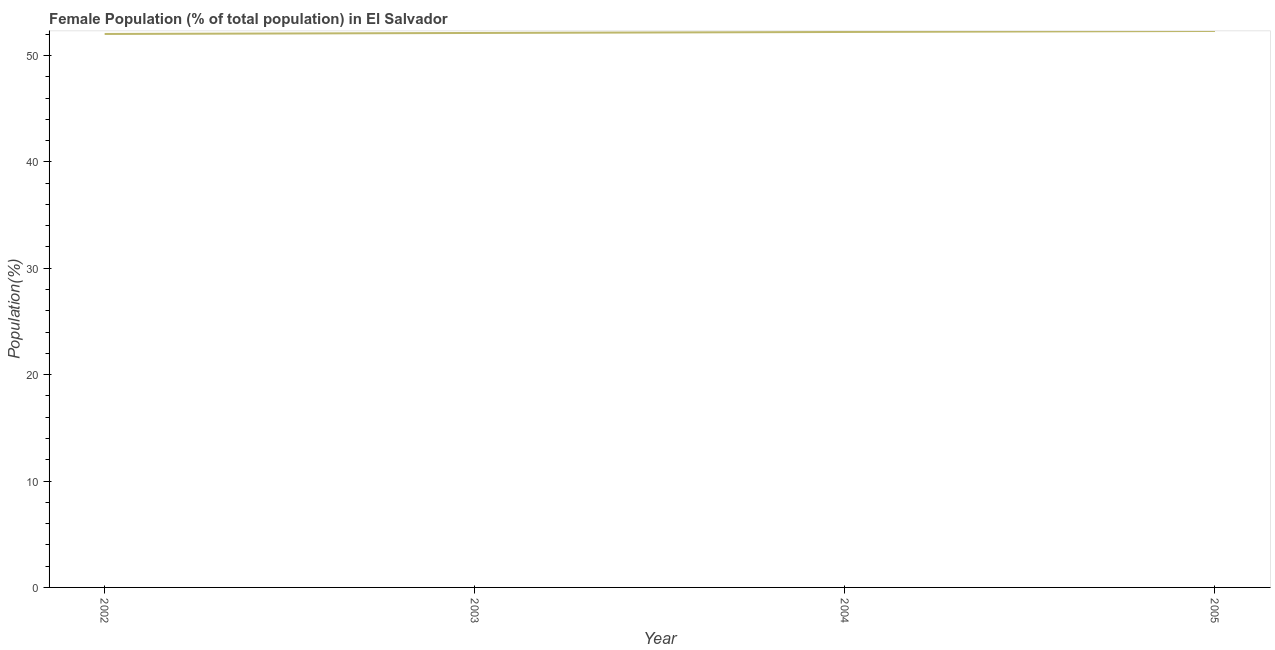What is the female population in 2004?
Make the answer very short. 52.21. Across all years, what is the maximum female population?
Ensure brevity in your answer.  52.3. Across all years, what is the minimum female population?
Offer a very short reply. 52.02. In which year was the female population maximum?
Your response must be concise. 2005. What is the sum of the female population?
Give a very brief answer. 208.65. What is the difference between the female population in 2003 and 2004?
Keep it short and to the point. -0.09. What is the average female population per year?
Provide a succinct answer. 52.16. What is the median female population?
Offer a very short reply. 52.16. In how many years, is the female population greater than 30 %?
Give a very brief answer. 4. What is the ratio of the female population in 2002 to that in 2004?
Your answer should be compact. 1. Is the female population in 2002 less than that in 2004?
Keep it short and to the point. Yes. What is the difference between the highest and the second highest female population?
Your response must be concise. 0.09. Is the sum of the female population in 2003 and 2004 greater than the maximum female population across all years?
Provide a succinct answer. Yes. What is the difference between the highest and the lowest female population?
Your response must be concise. 0.28. In how many years, is the female population greater than the average female population taken over all years?
Offer a terse response. 2. Does the female population monotonically increase over the years?
Ensure brevity in your answer.  Yes. How many lines are there?
Make the answer very short. 1. What is the title of the graph?
Ensure brevity in your answer.  Female Population (% of total population) in El Salvador. What is the label or title of the Y-axis?
Give a very brief answer. Population(%). What is the Population(%) in 2002?
Your answer should be compact. 52.02. What is the Population(%) of 2003?
Your response must be concise. 52.12. What is the Population(%) of 2004?
Your response must be concise. 52.21. What is the Population(%) of 2005?
Your answer should be very brief. 52.3. What is the difference between the Population(%) in 2002 and 2003?
Your answer should be very brief. -0.09. What is the difference between the Population(%) in 2002 and 2004?
Provide a succinct answer. -0.19. What is the difference between the Population(%) in 2002 and 2005?
Keep it short and to the point. -0.28. What is the difference between the Population(%) in 2003 and 2004?
Keep it short and to the point. -0.09. What is the difference between the Population(%) in 2003 and 2005?
Your answer should be compact. -0.19. What is the difference between the Population(%) in 2004 and 2005?
Your answer should be compact. -0.09. What is the ratio of the Population(%) in 2002 to that in 2004?
Give a very brief answer. 1. What is the ratio of the Population(%) in 2003 to that in 2004?
Ensure brevity in your answer.  1. What is the ratio of the Population(%) in 2003 to that in 2005?
Offer a very short reply. 1. What is the ratio of the Population(%) in 2004 to that in 2005?
Provide a short and direct response. 1. 